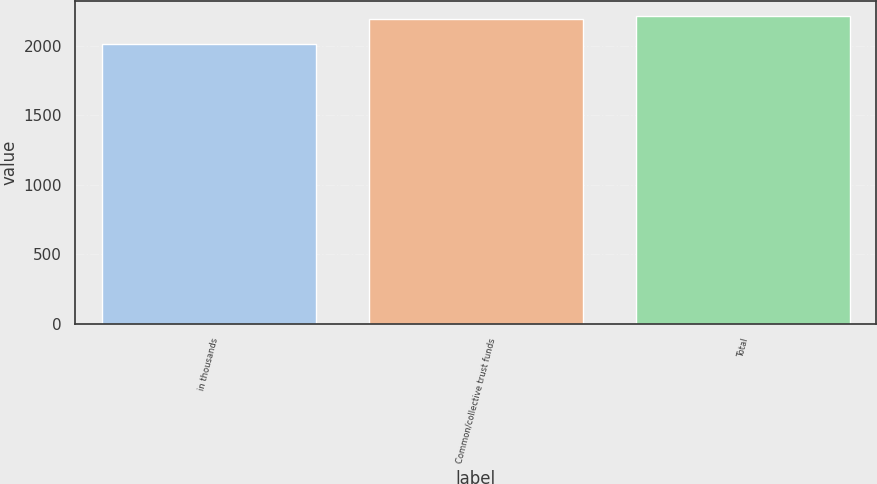<chart> <loc_0><loc_0><loc_500><loc_500><bar_chart><fcel>in thousands<fcel>Common/collective trust funds<fcel>Total<nl><fcel>2011<fcel>2192<fcel>2210.1<nl></chart> 